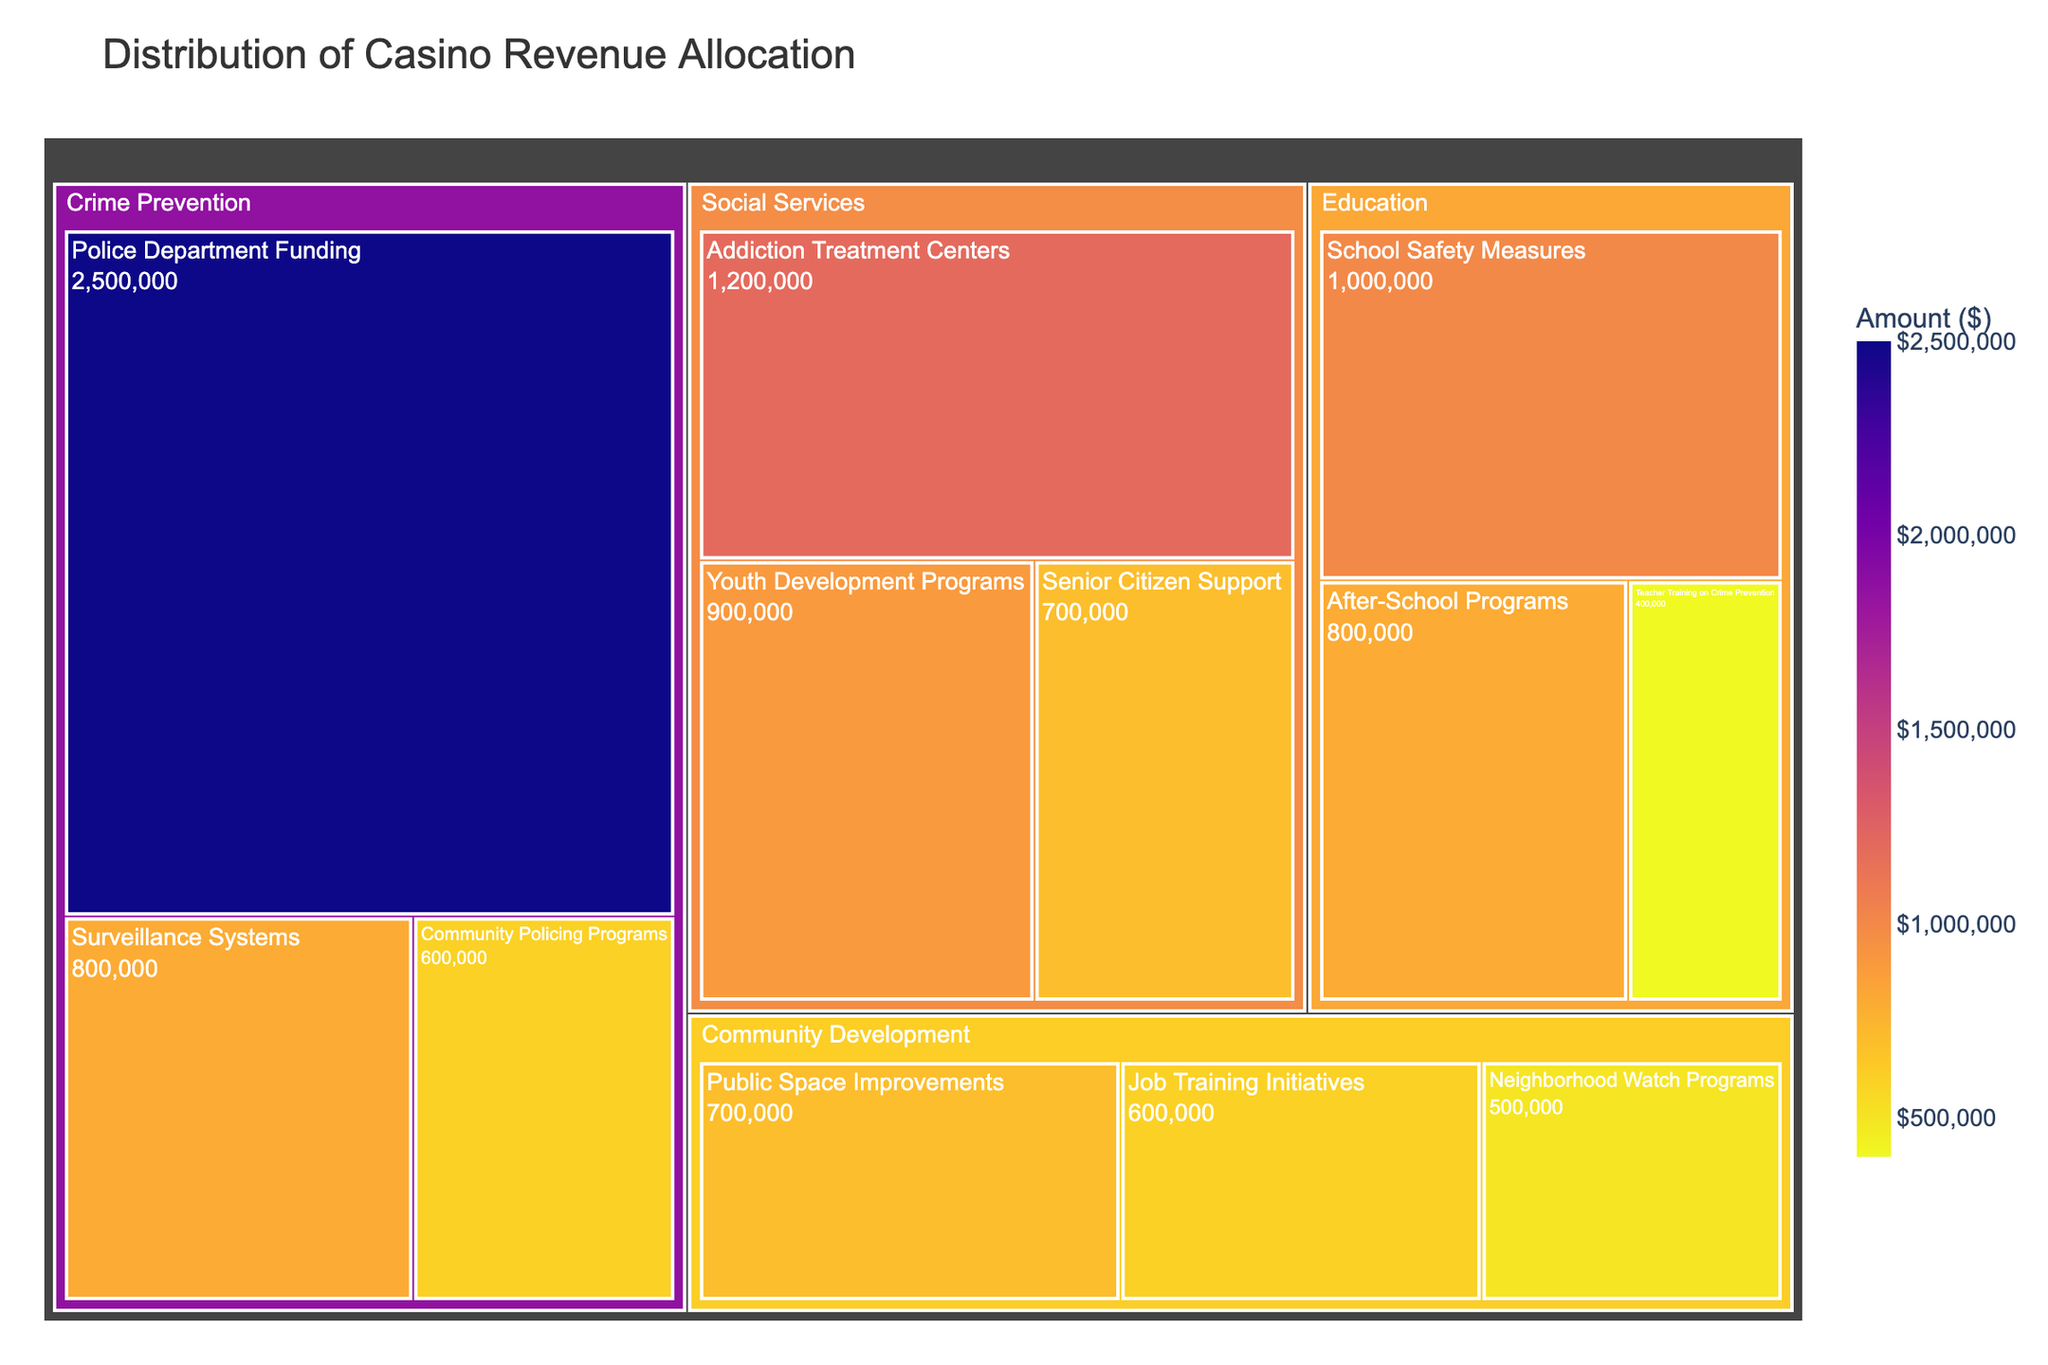What is the title of the treemap? The title is usually located at the top of the figure, providing a summary of what the chart represents.
Answer: Distribution of Casino Revenue Allocation Which category received the highest amount of casino revenue? Scan the treemap for the category with the largest area or inspect the hover data for precise amounts. The category with the largest allocation will stand out.
Answer: Crime Prevention How much money was allocated to Addiction Treatment Centers? Look for the subcategory "Addiction Treatment Centers" in the Social Services category. Check the amount displayed in the corresponding box or hover over it.
Answer: $1,200,000 Compare the funding for School Safety Measures and Community Policing Programs. Which one received more funds? Locate both subcategories in the treemap and compare their values. School Safety Measures is in the Education category, while Community Policing Programs is in Crime Prevention.
Answer: School Safety Measures received more funds What percentage of the total allocation went to Senior Citizen Support? First, find the amount allocated to Senior Citizen Support, which is $700,000. Then sum the total amount of all allocations and divide the Senior Citizen Support amount by this total, multiplying by 100 to get the percentage.
Answer: 7.37% What is the combined total of the allocations for Social Services? Add up the amounts for all subcategories under Social Services: Addiction Treatment Centers ($1,200,000), Youth Development Programs ($900,000), and Senior Citizen Support ($700,000).
Answer: $2,800,000 Which subcategory within Community Development has the largest allocation? Look within the Community Development category and identify the subcategory with the largest box or value.
Answer: Public Space Improvements Between Neighborhood Watch Programs and Job Training Initiatives, which subcategory received less funding? Compare the amounts of Neighborhood Watch Programs and Job Training Initiatives in the Community Development category.
Answer: Neighborhood Watch Programs What is the total amount allocated to all crime prevention initiatives combined? Sum the amounts for all subcategories under Crime Prevention: Police Department Funding ($2,500,000), Surveillance Systems ($800,000), and Community Policing Programs ($600,000).
Answer: $3,900,000 How does the allocation for Youth Development Programs compare with After-School Programs? Identify the amounts for both Youth Development Programs ($900,000) in Social Services and After-School Programs ($800,000) in Education, and compare them.
Answer: Youth Development Programs received more 